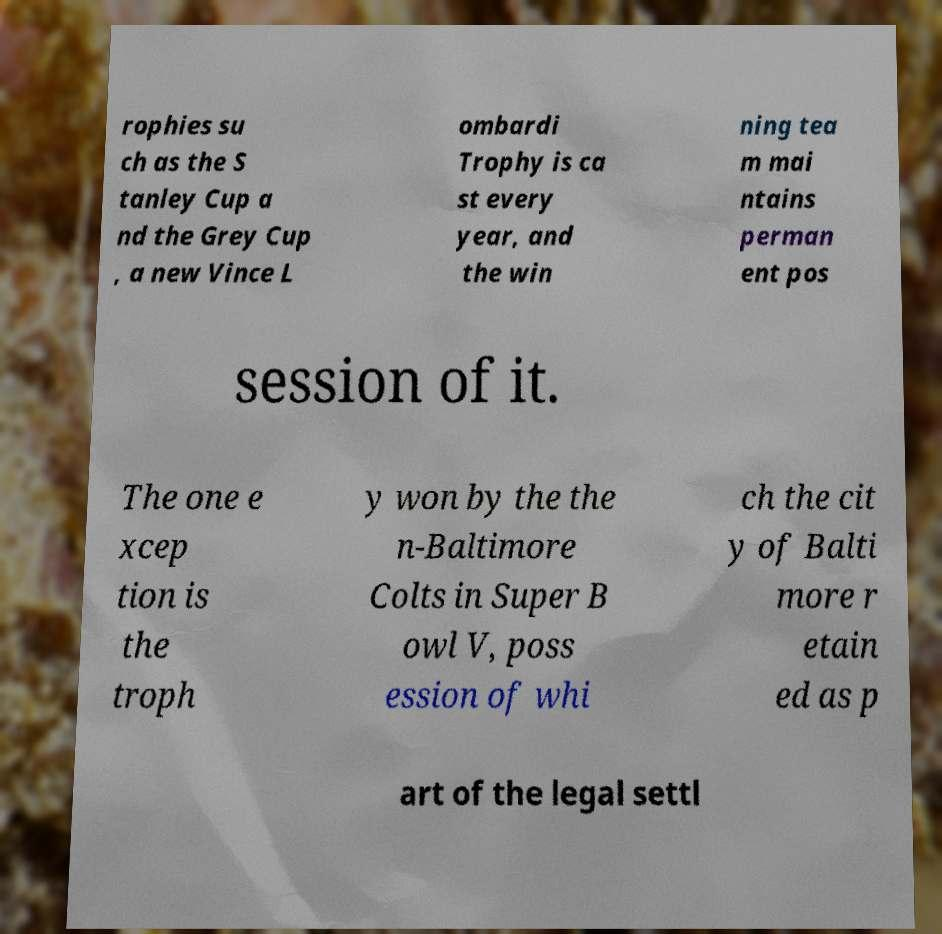Could you extract and type out the text from this image? rophies su ch as the S tanley Cup a nd the Grey Cup , a new Vince L ombardi Trophy is ca st every year, and the win ning tea m mai ntains perman ent pos session of it. The one e xcep tion is the troph y won by the the n-Baltimore Colts in Super B owl V, poss ession of whi ch the cit y of Balti more r etain ed as p art of the legal settl 